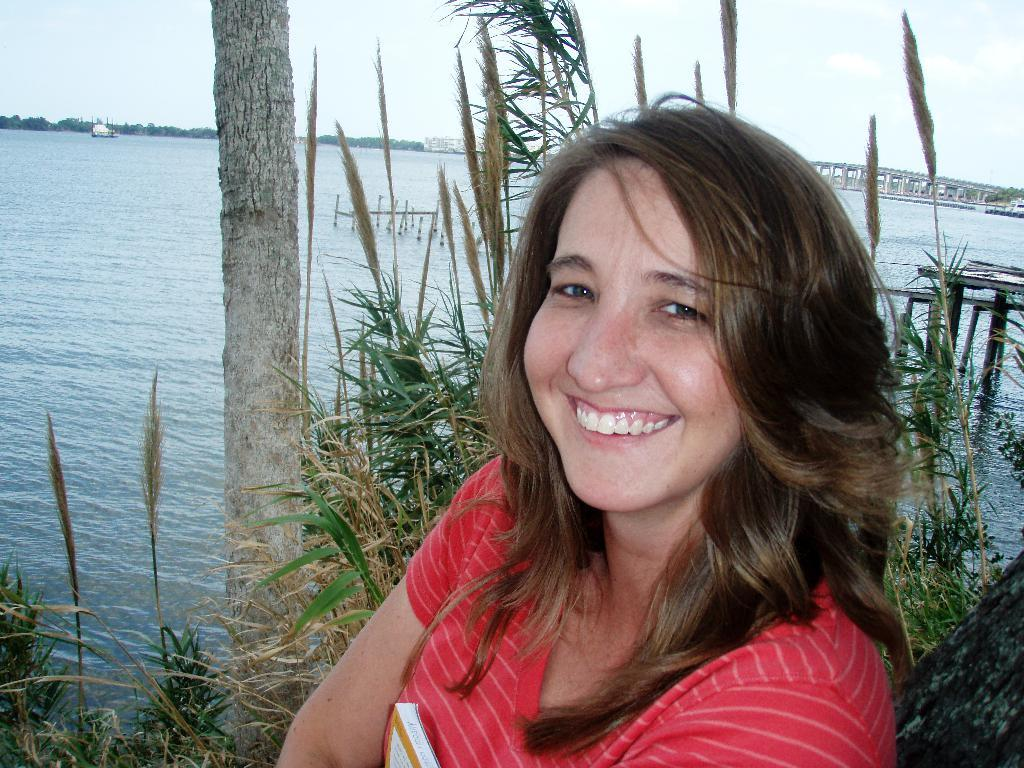Who is the main subject in the foreground of the image? There is a woman in the foreground of the image. What is the woman doing in the image? The woman is laughing. What can be seen behind the woman? There are plants and a water surface visible behind the woman. What type of vegetation is in the background of the image? There are trees in the background of the image. Where is the market located in the image? There is no market present in the image. What is the woman's side doing in the image? The woman is the main subject in the image, and there is no mention of a side or any specific body part. 